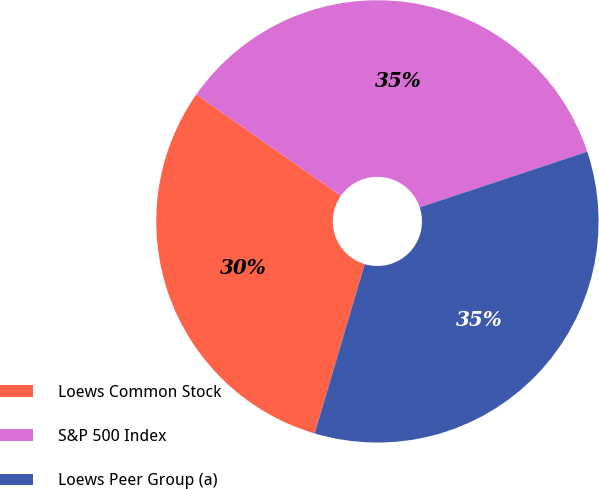Convert chart to OTSL. <chart><loc_0><loc_0><loc_500><loc_500><pie_chart><fcel>Loews Common Stock<fcel>S&P 500 Index<fcel>Loews Peer Group (a)<nl><fcel>30.15%<fcel>35.17%<fcel>34.68%<nl></chart> 